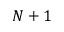Convert formula to latex. <formula><loc_0><loc_0><loc_500><loc_500>N + 1</formula> 